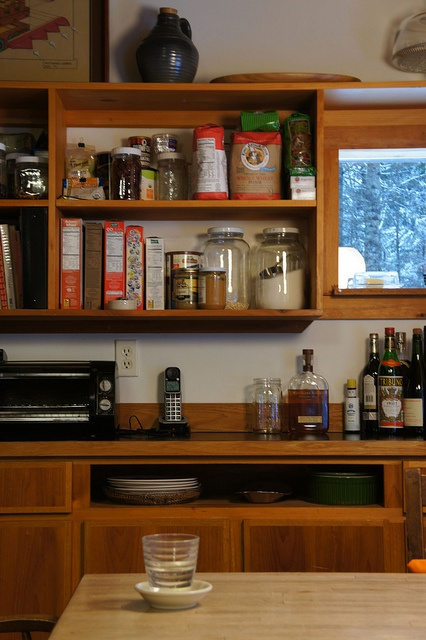Describe the objects in this image and their specific colors. I can see dining table in maroon, tan, and olive tones, microwave in maroon, black, gray, darkgreen, and darkgray tones, toaster in maroon, black, gray, darkgray, and darkgreen tones, bottle in maroon, tan, olive, and black tones, and cup in maroon, gray, brown, and tan tones in this image. 